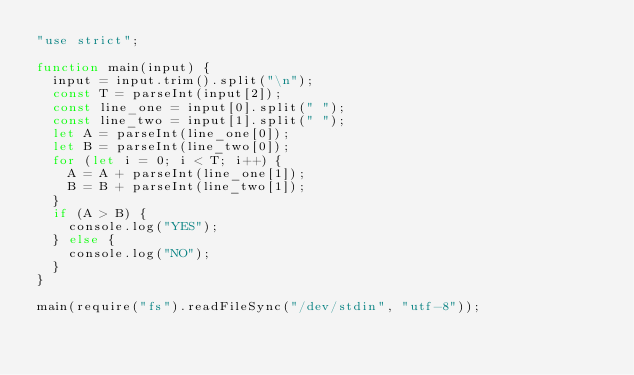<code> <loc_0><loc_0><loc_500><loc_500><_JavaScript_>"use strict";

function main(input) {
  input = input.trim().split("\n");
  const T = parseInt(input[2]);
  const line_one = input[0].split(" ");
  const line_two = input[1].split(" ");
  let A = parseInt(line_one[0]);
  let B = parseInt(line_two[0]);
  for (let i = 0; i < T; i++) {
    A = A + parseInt(line_one[1]);
    B = B + parseInt(line_two[1]);
  }
  if (A > B) {
    console.log("YES");
  } else {
    console.log("NO");
  }
}

main(require("fs").readFileSync("/dev/stdin", "utf-8"));
</code> 